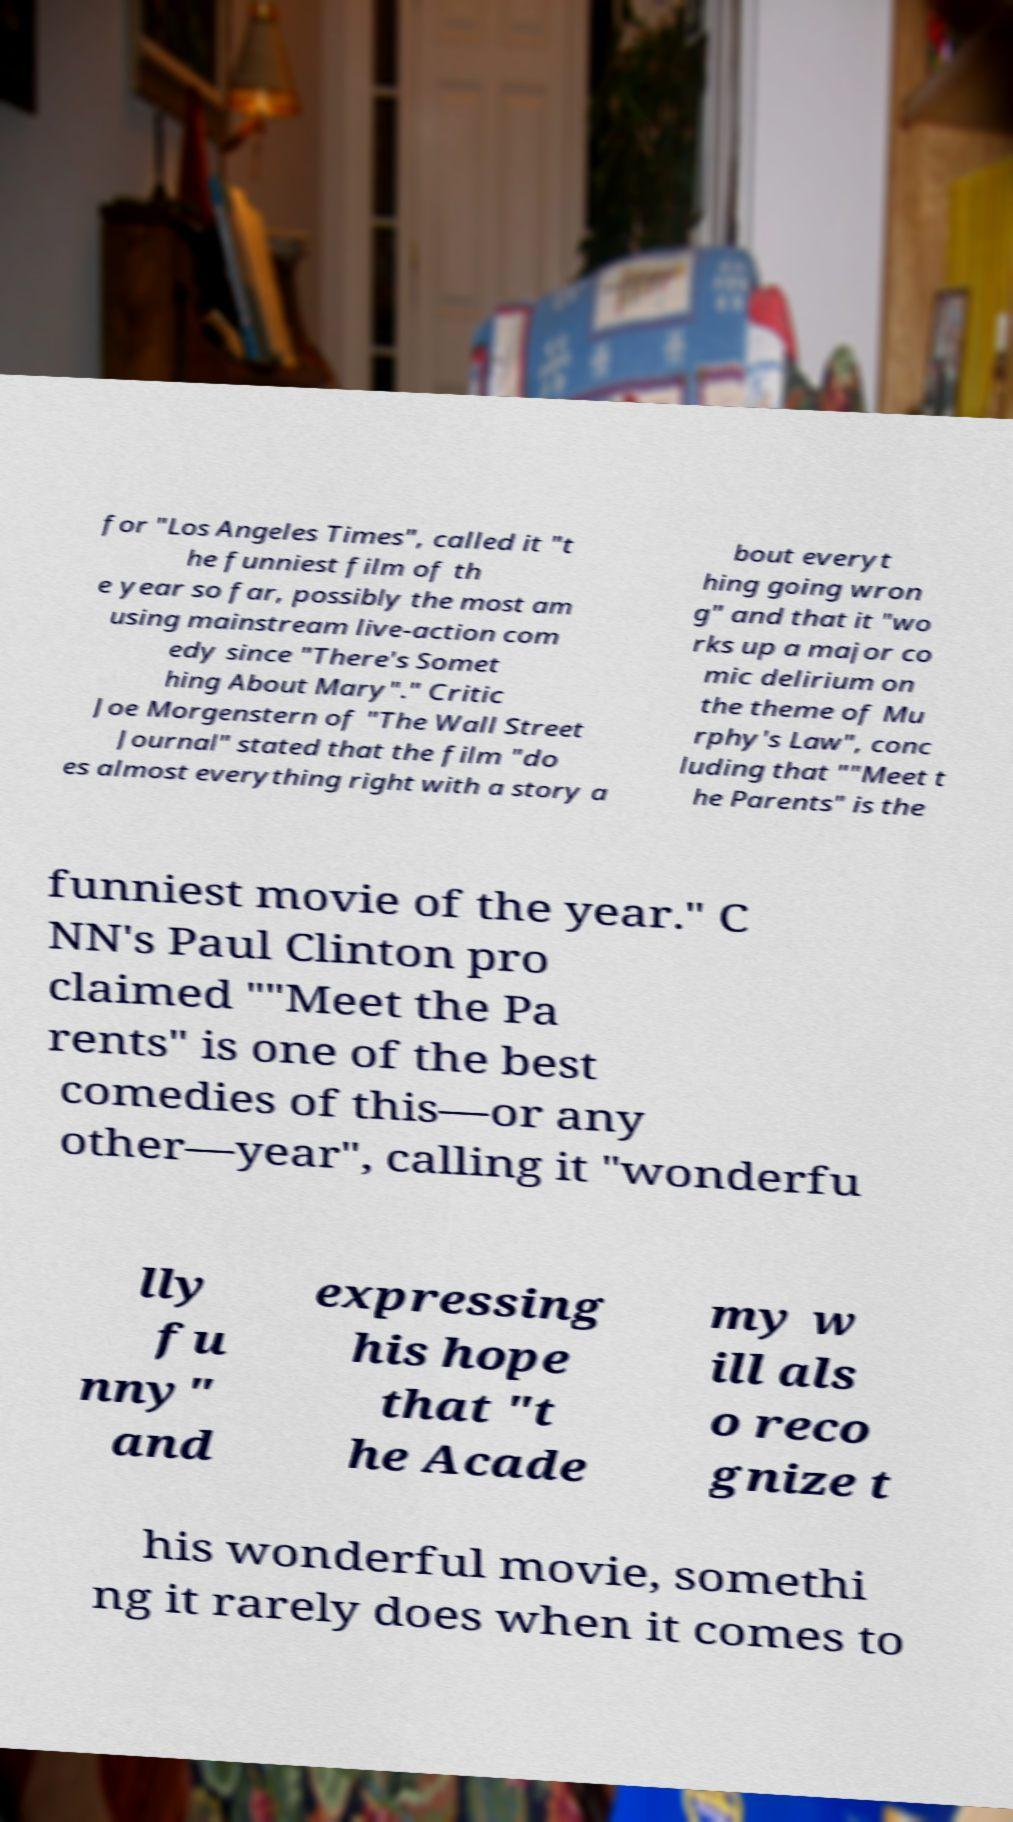I need the written content from this picture converted into text. Can you do that? for "Los Angeles Times", called it "t he funniest film of th e year so far, possibly the most am using mainstream live-action com edy since "There's Somet hing About Mary"." Critic Joe Morgenstern of "The Wall Street Journal" stated that the film "do es almost everything right with a story a bout everyt hing going wron g" and that it "wo rks up a major co mic delirium on the theme of Mu rphy's Law", conc luding that ""Meet t he Parents" is the funniest movie of the year." C NN's Paul Clinton pro claimed ""Meet the Pa rents" is one of the best comedies of this—or any other—year", calling it "wonderfu lly fu nny" and expressing his hope that "t he Acade my w ill als o reco gnize t his wonderful movie, somethi ng it rarely does when it comes to 